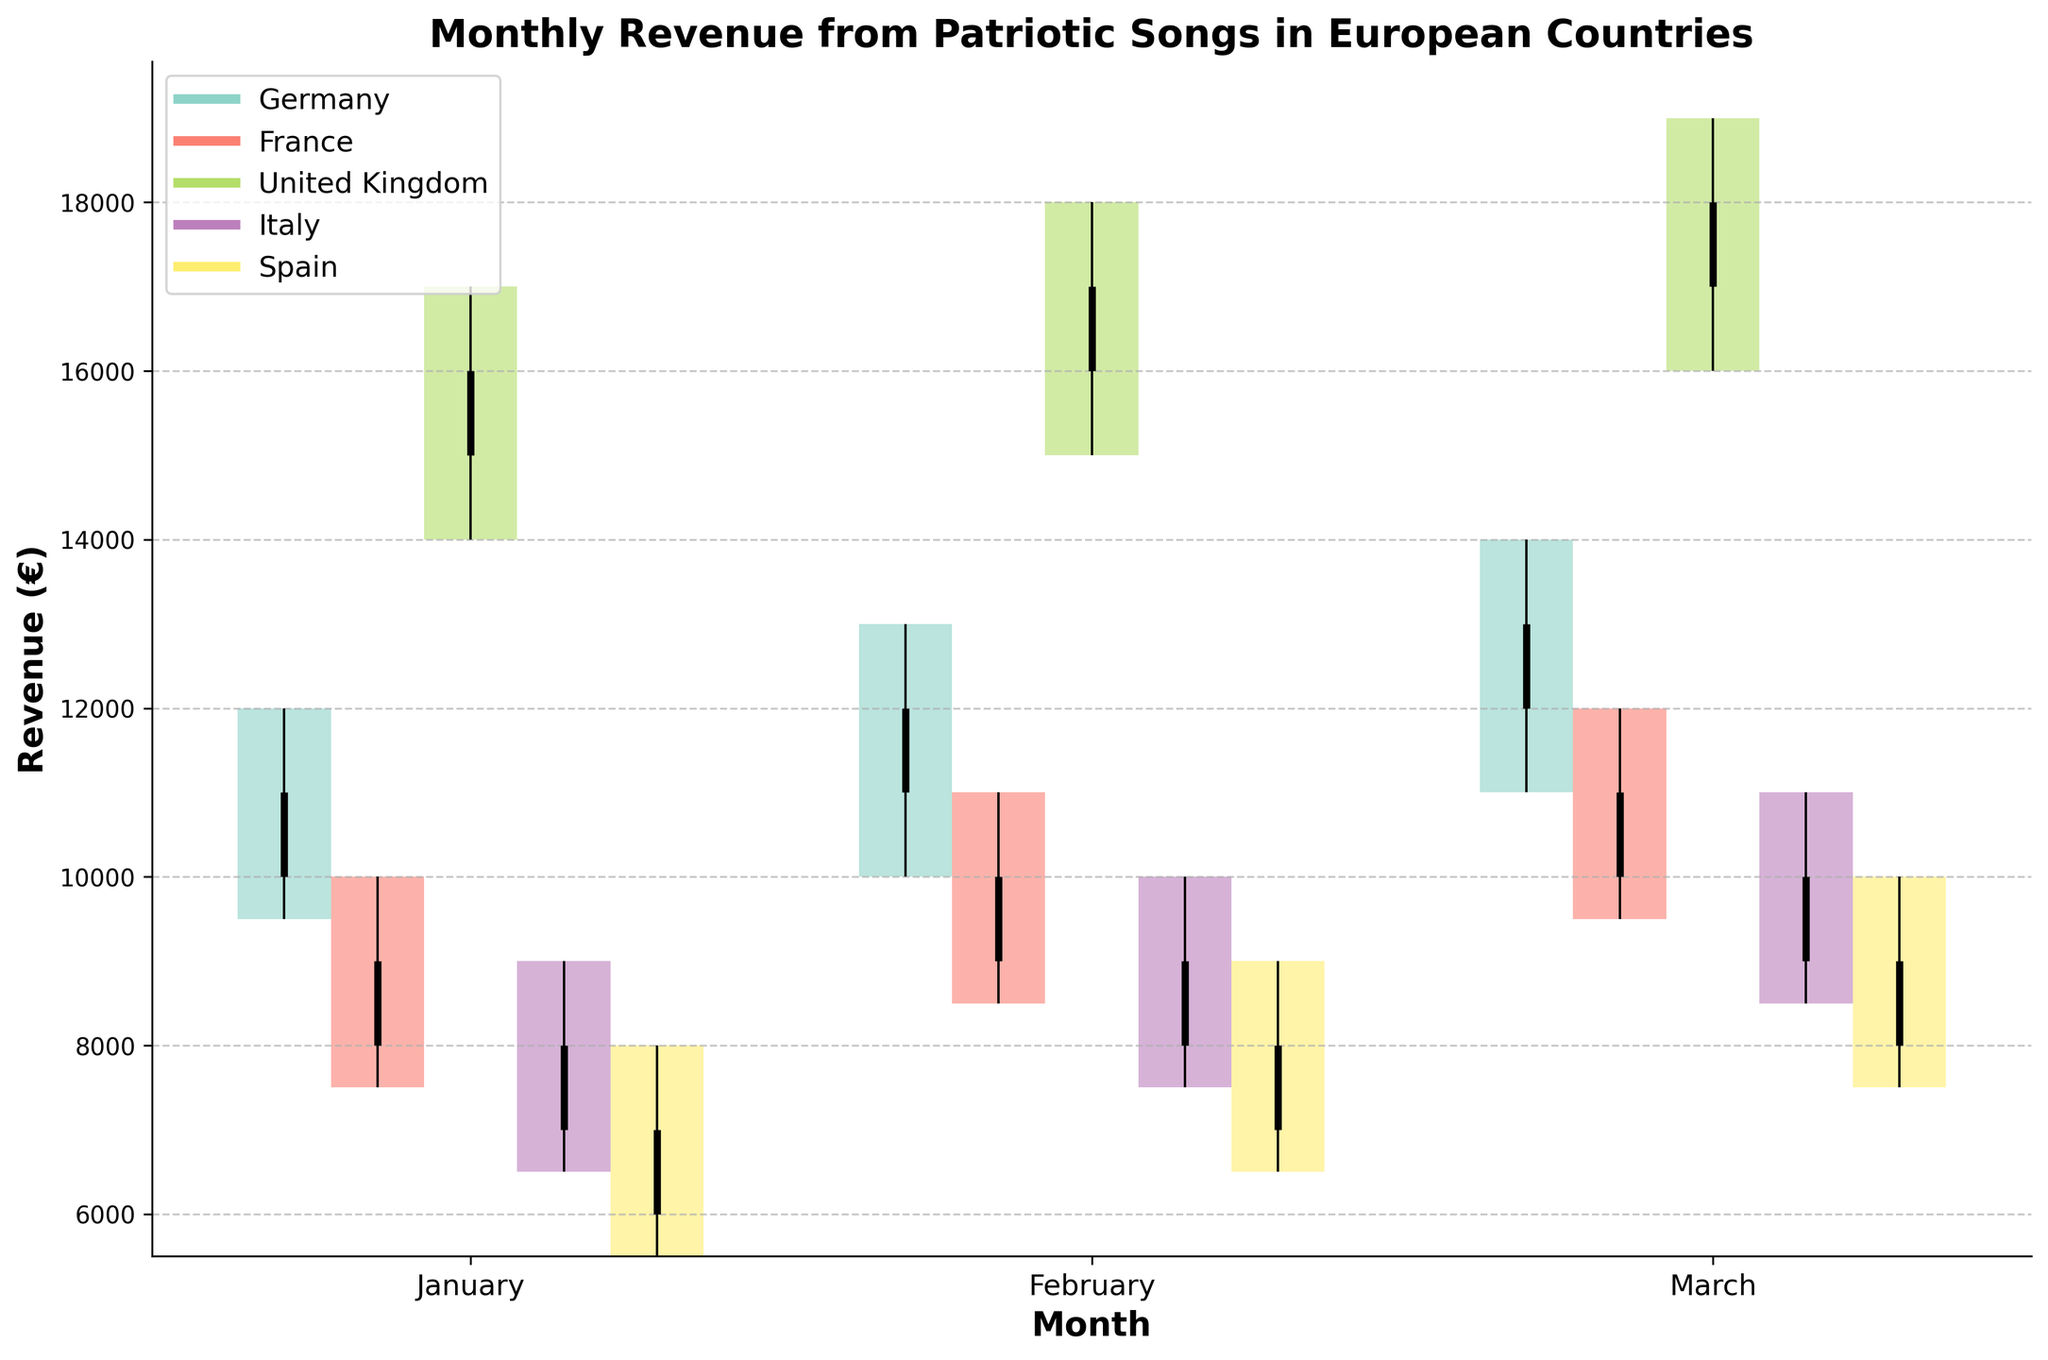What is the title of the plot? The title of the plot is displayed at the top.
Answer: Monthly Revenue from Patriotic Songs in European Countries Which country had the highest revenue in March? Look for the country with the highest "High" value in March.
Answer: United Kingdom What was the closing revenue for Germany in January? Refer to the "Close" value for Germany in January.
Answer: 11000 Between Germany and France, which country showed a higher revenue in February? Compare the "High" values for Germany and France in February.
Answer: Germany What is the average opening revenue for Spain across the three months? Sum the "Open" values for Spain (6000, 7000, 8000) and divide by 3.
Answer: 7000 Which country had the largest difference between high and low values in January? Calculate the difference (High - Low) for each country in January and compare.
Answer: United Kingdom How does the revenue trend in March compare between Italy and France? Compare opening (Open) and closing (Close) values for Italy and France in March. Both show increasing trends, but Italy starts lower and ends higher.
Answer: Italy rises more sharply What is the range of revenue for the United Kingdom in February? Subtract the "Low" value from the "High" value for the United Kingdom in February (18000 - 15000).
Answer: 3000 Which month showed the highest revenue for Italy? Compare the "High" values for Italy across all months.
Answer: March In which month did Germany see the smallest range of revenue? Calculate the range (High - Low) for Germany across all months and find the smallest.
Answer: February 